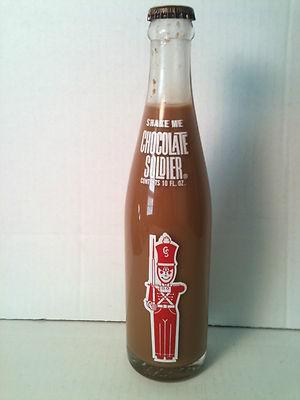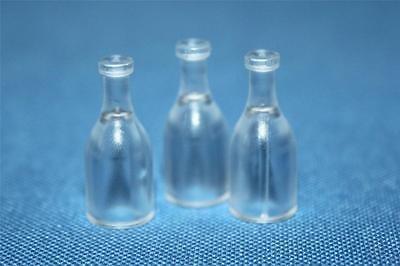The first image is the image on the left, the second image is the image on the right. For the images shown, is this caption "Each image shows a single glass bottle, at least one of the pictured bottles is empty, and at least one bottle has a red 'toy soldier' depicted on the front." true? Answer yes or no. No. The first image is the image on the left, the second image is the image on the right. For the images shown, is this caption "The right image contains exactly three bottles." true? Answer yes or no. Yes. 